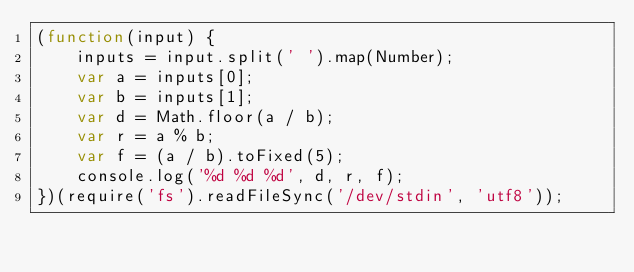Convert code to text. <code><loc_0><loc_0><loc_500><loc_500><_JavaScript_>(function(input) {
    inputs = input.split(' ').map(Number);
    var a = inputs[0];
    var b = inputs[1];
    var d = Math.floor(a / b);
    var r = a % b;
    var f = (a / b).toFixed(5);
    console.log('%d %d %d', d, r, f);
})(require('fs').readFileSync('/dev/stdin', 'utf8'));</code> 